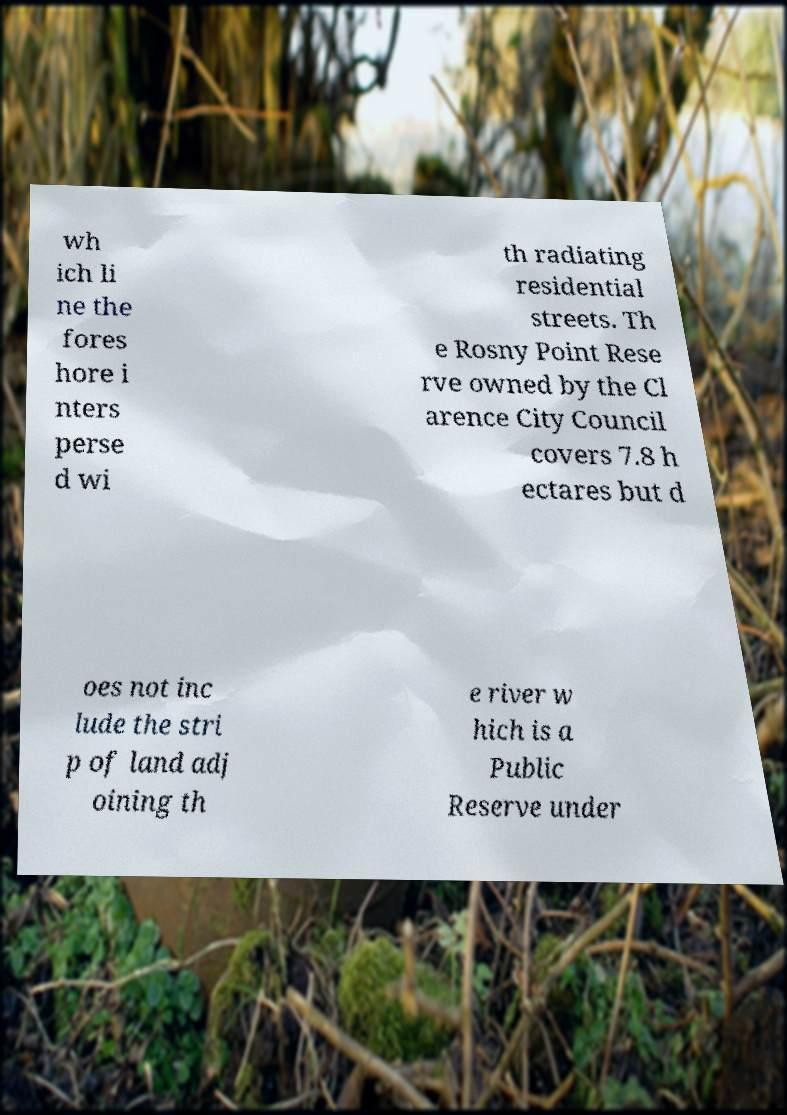There's text embedded in this image that I need extracted. Can you transcribe it verbatim? wh ich li ne the fores hore i nters perse d wi th radiating residential streets. Th e Rosny Point Rese rve owned by the Cl arence City Council covers 7.8 h ectares but d oes not inc lude the stri p of land adj oining th e river w hich is a Public Reserve under 